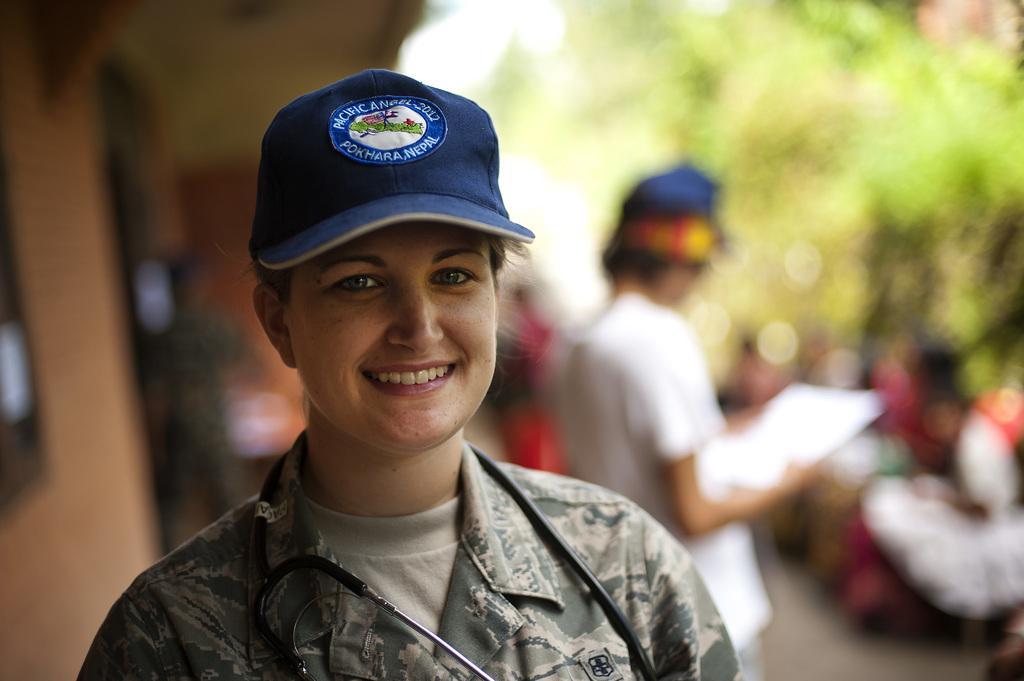Can you describe this image briefly? In the foreground of this image, there is a woman wearing stethoscope and a cap on her head. Behind her, there is a person standing and holding an object and remaining objects are not clear. 